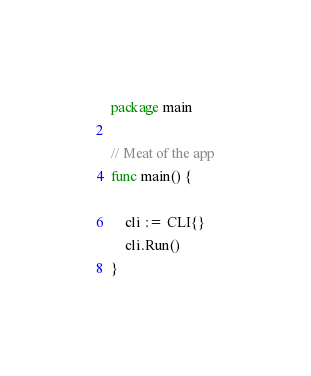Convert code to text. <code><loc_0><loc_0><loc_500><loc_500><_Go_>package main

// Meat of the app
func main() {

	cli := CLI{}
	cli.Run()
}
</code> 